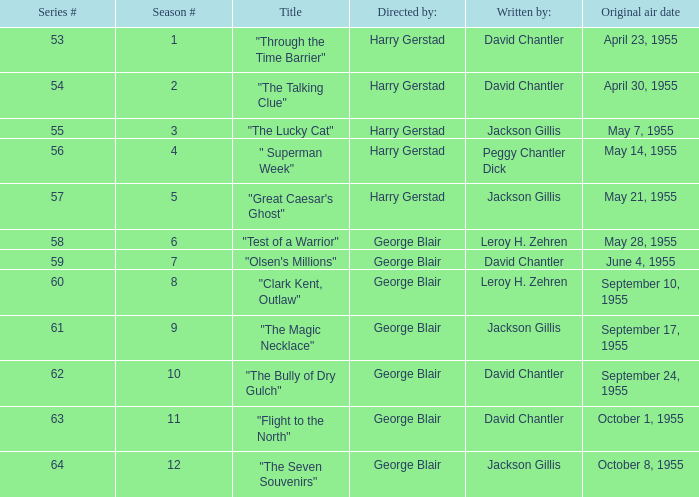Who was "The Magic Necklace" written by? Jackson Gillis. 